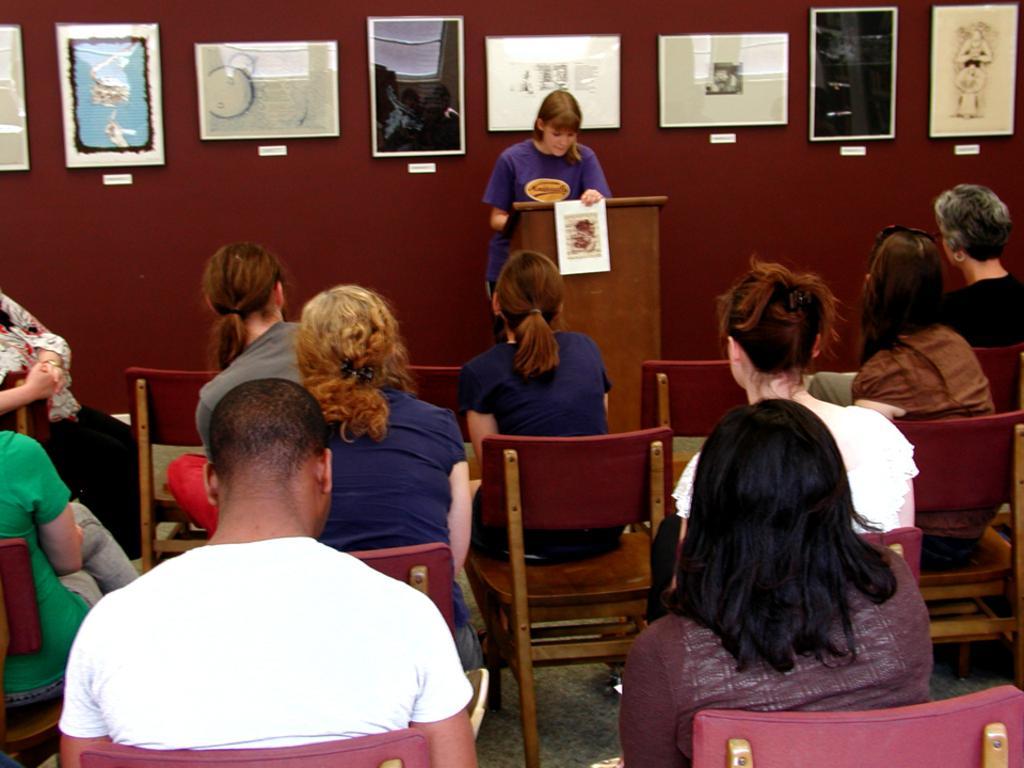Could you give a brief overview of what you see in this image? In this image i can see group of people sitting on a chair there is a women standing, in front of a woman there is a podium at the background there few frames attached to a wall. 